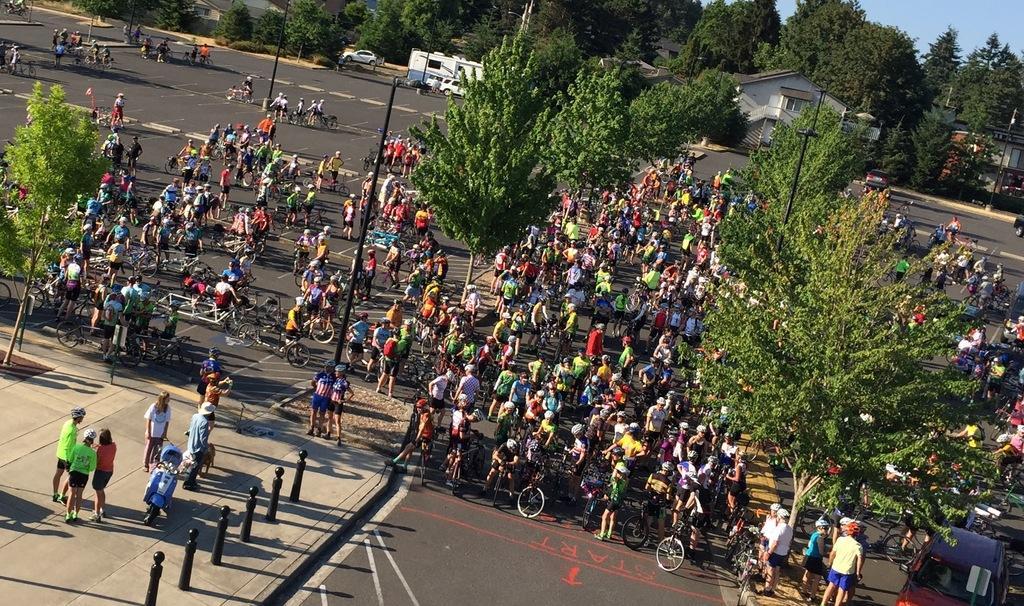Can you describe this image briefly? In this image, there are a few people, trees, poles, houses, vehicles and bicycles. We can see the ground with some objects. We can also see the sky. 